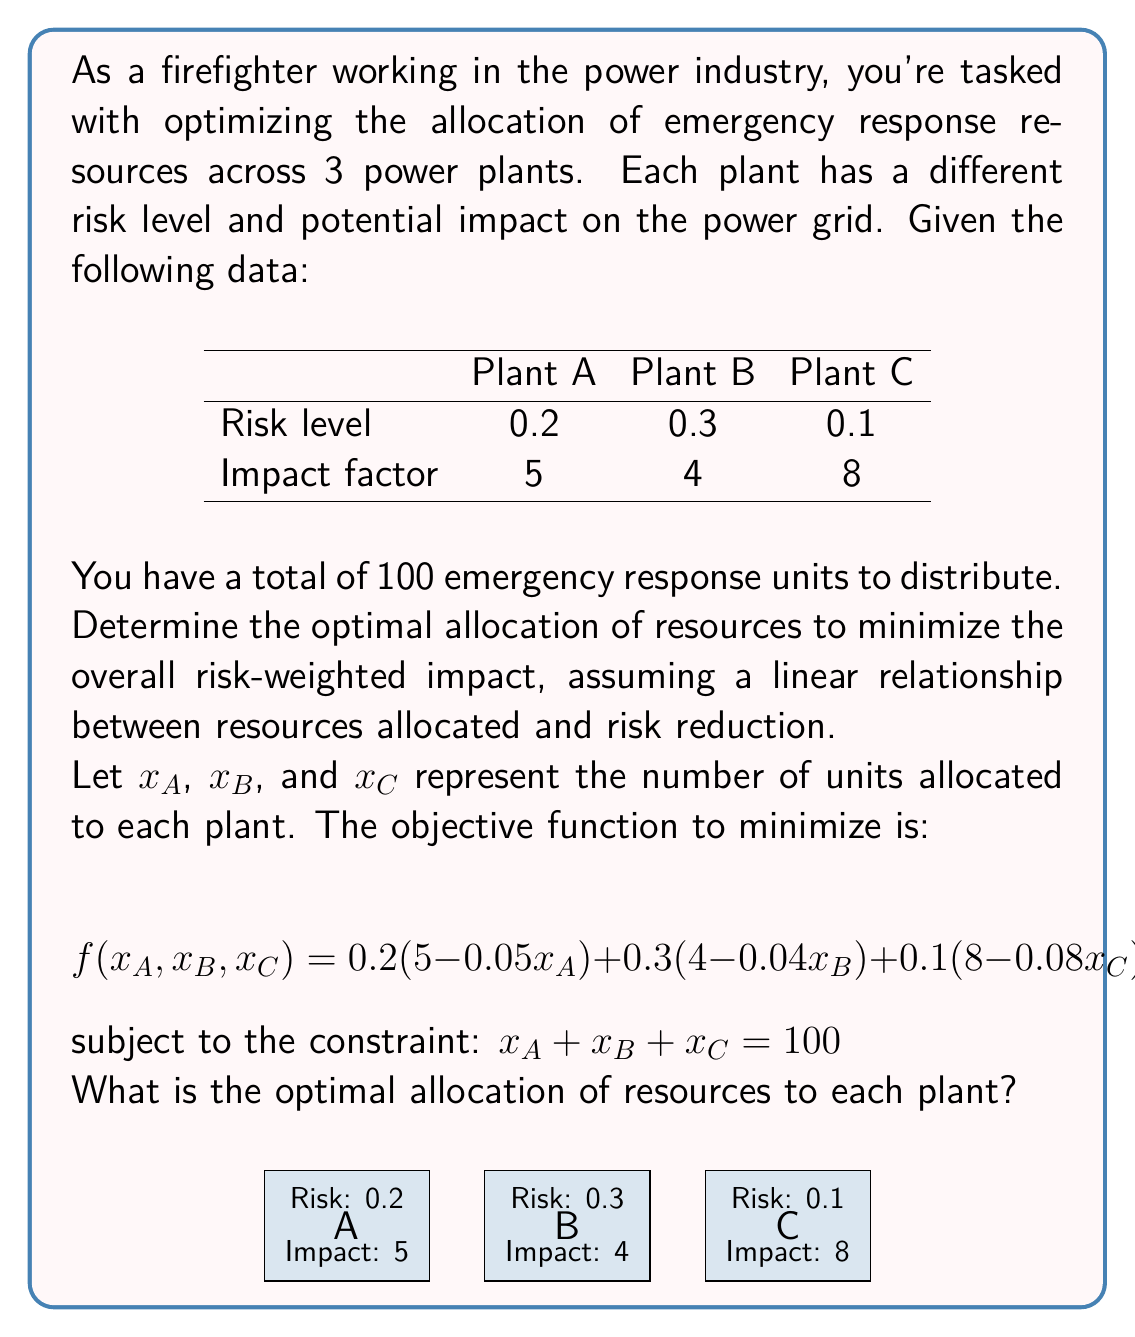What is the answer to this math problem? To solve this optimization problem, we'll use the method of Lagrange multipliers:

1) Form the Lagrangian function:
   $$ L(x_A, x_B, x_C, \lambda) = 0.2(5-0.05x_A) + 0.3(4-0.04x_B) + 0.1(8-0.08x_C) + \lambda(x_A + x_B + x_C - 100) $$

2) Take partial derivatives and set them to zero:
   $$ \frac{\partial L}{\partial x_A} = -0.01 + \lambda = 0 $$
   $$ \frac{\partial L}{\partial x_B} = -0.012 + \lambda = 0 $$
   $$ \frac{\partial L}{\partial x_C} = -0.008 + \lambda = 0 $$
   $$ \frac{\partial L}{\partial \lambda} = x_A + x_B + x_C - 100 = 0 $$

3) From these equations, we can deduce:
   $\lambda = 0.01 = 0.012 = 0.008$

   This is impossible, indicating that the optimal solution lies on the boundary of the feasible region.

4) Compare the coefficients in the objective function:
   Plant A: $0.2 \times 0.05 = 0.01$
   Plant B: $0.3 \times 0.04 = 0.012$
   Plant C: $0.1 \times 0.08 = 0.008$

5) Allocate resources in descending order of these coefficients:
   First to B (40 units), then to A (40 units), and finally to C (20 units).

6) Verify the constraint: 40 + 40 + 20 = 100 units
Answer: Plant A: 40 units, Plant B: 40 units, Plant C: 20 units 